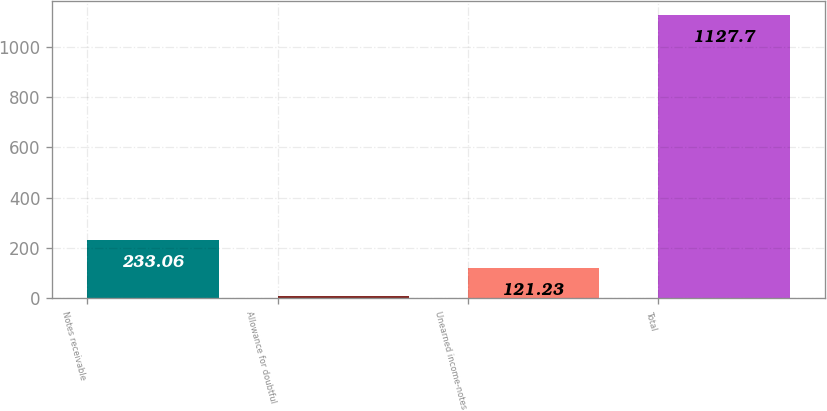Convert chart to OTSL. <chart><loc_0><loc_0><loc_500><loc_500><bar_chart><fcel>Notes receivable<fcel>Allowance for doubtful<fcel>Unearned income-notes<fcel>Total<nl><fcel>233.06<fcel>9.4<fcel>121.23<fcel>1127.7<nl></chart> 